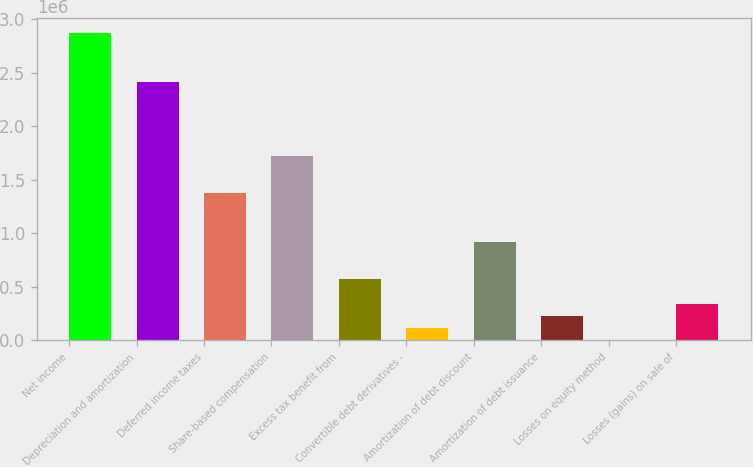<chart> <loc_0><loc_0><loc_500><loc_500><bar_chart><fcel>Net income<fcel>Depreciation and amortization<fcel>Deferred income taxes<fcel>Share-based compensation<fcel>Excess tax benefit from<fcel>Convertible debt derivatives -<fcel>Amortization of debt discount<fcel>Amortization of debt issuance<fcel>Losses on equity method<fcel>Losses (gains) on sale of<nl><fcel>2.87257e+06<fcel>2.41299e+06<fcel>1.37894e+06<fcel>1.72362e+06<fcel>574670<fcel>115090<fcel>919355<fcel>229985<fcel>195<fcel>344880<nl></chart> 